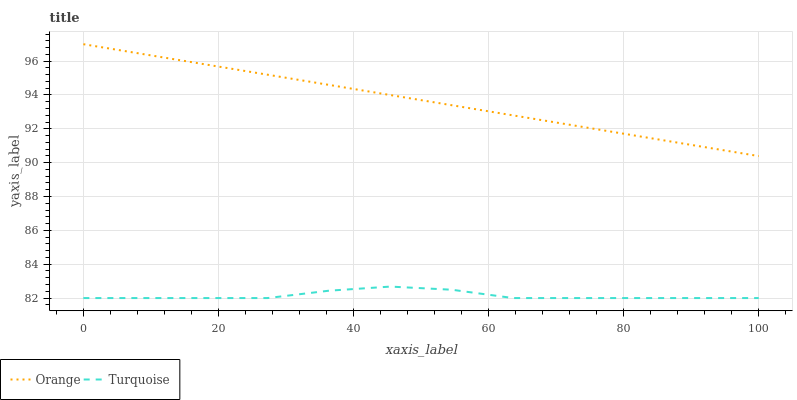Does Turquoise have the minimum area under the curve?
Answer yes or no. Yes. Does Orange have the maximum area under the curve?
Answer yes or no. Yes. Does Turquoise have the maximum area under the curve?
Answer yes or no. No. Is Orange the smoothest?
Answer yes or no. Yes. Is Turquoise the roughest?
Answer yes or no. Yes. Is Turquoise the smoothest?
Answer yes or no. No. Does Turquoise have the lowest value?
Answer yes or no. Yes. Does Orange have the highest value?
Answer yes or no. Yes. Does Turquoise have the highest value?
Answer yes or no. No. Is Turquoise less than Orange?
Answer yes or no. Yes. Is Orange greater than Turquoise?
Answer yes or no. Yes. Does Turquoise intersect Orange?
Answer yes or no. No. 